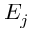<formula> <loc_0><loc_0><loc_500><loc_500>E _ { j }</formula> 